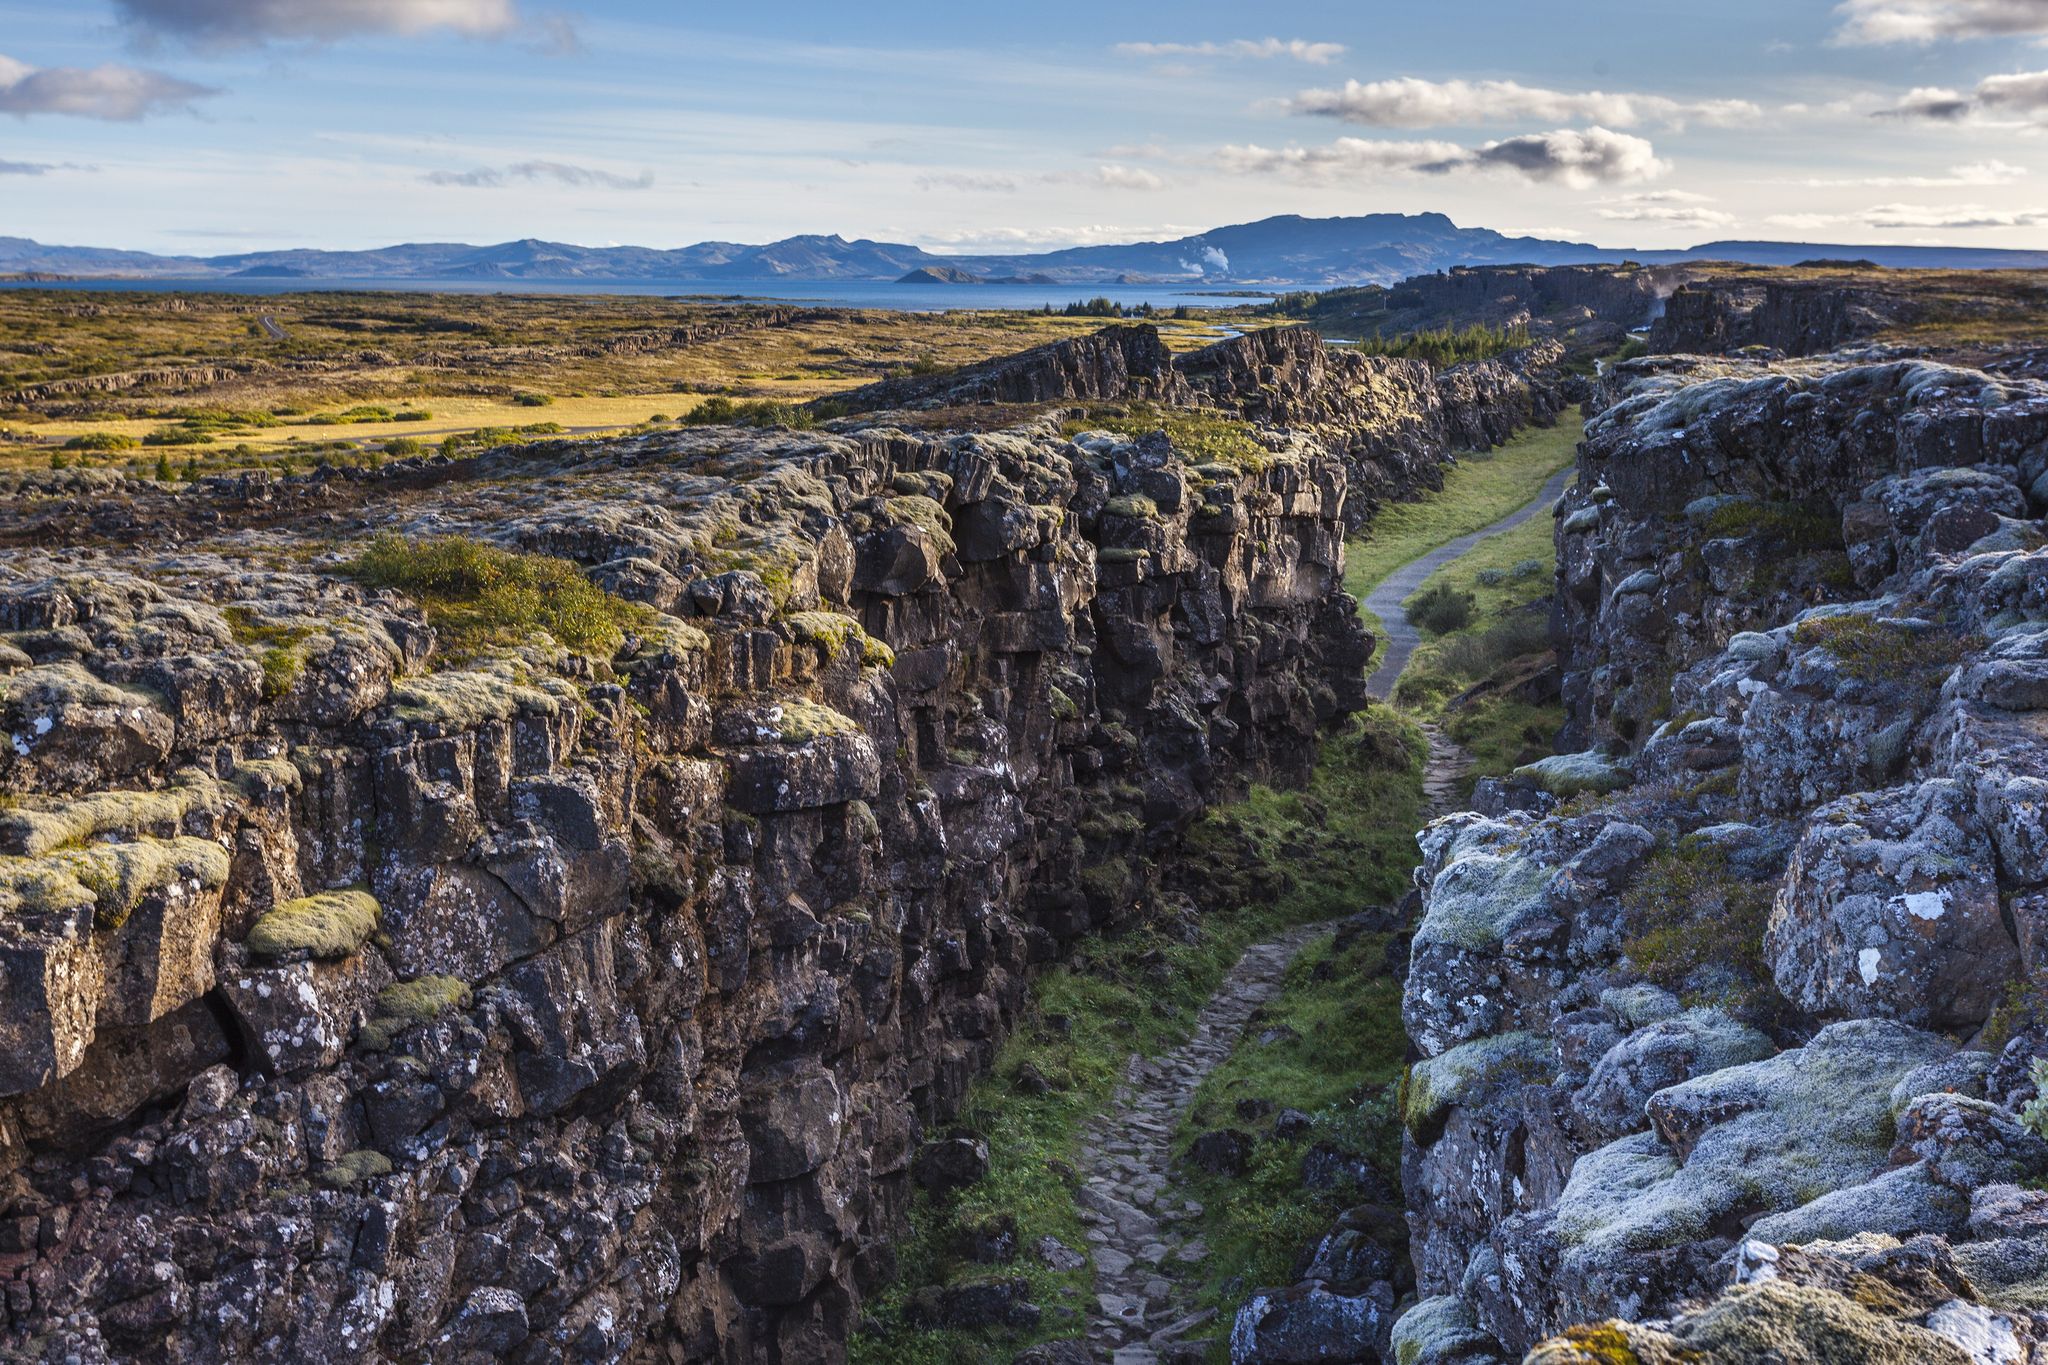Imagine discovering a hidden cave in the gorge. What might it be like inside? Discovering a hidden cave in the gorge of Þingvellir would be an extraordinary adventure. As you step inside, the temperature drops, and the air becomes cool and damp. The cave walls are adorned with luminous moss and lichen that emit a faint, greenish glow, providing just enough light to navigate the interior. Stalactites and stalagmites create natural sculptures, with drops of water echoing softly as they fall. Deeper into the cave, chambers open up, revealing hidden pools of crystal-clear water, shimmering in the dim light. The quietness inside is profound, broken only by the occasional trickle of water and the rustling of unseen creatures. Ancient carvings on the walls hint at stories and legends from centuries past, adding to the sense of mystery and history. This hidden sanctuary offers a surreal and almost otherworldly experience, a retreat into the heart of Iceland's natural beauty and geological wonders. Could there be any ancient artifacts hidden in such a cave? It's entirely possible that ancient artifacts could be hidden within such a cave. Given Þingvellir's historical significance, remnants from past civilizations or early settlers of Iceland might be found. These artifacts could include tools, pottery, or even ceremonial items used by the early inhabitants. Discovering such items would offer valuable insights into the lives and cultures of those who lived here centuries ago. The cave, acting as a natural time capsule, could preserve these relics in remarkable condition, providing a tangible connection to the island's rich history and heritage. 